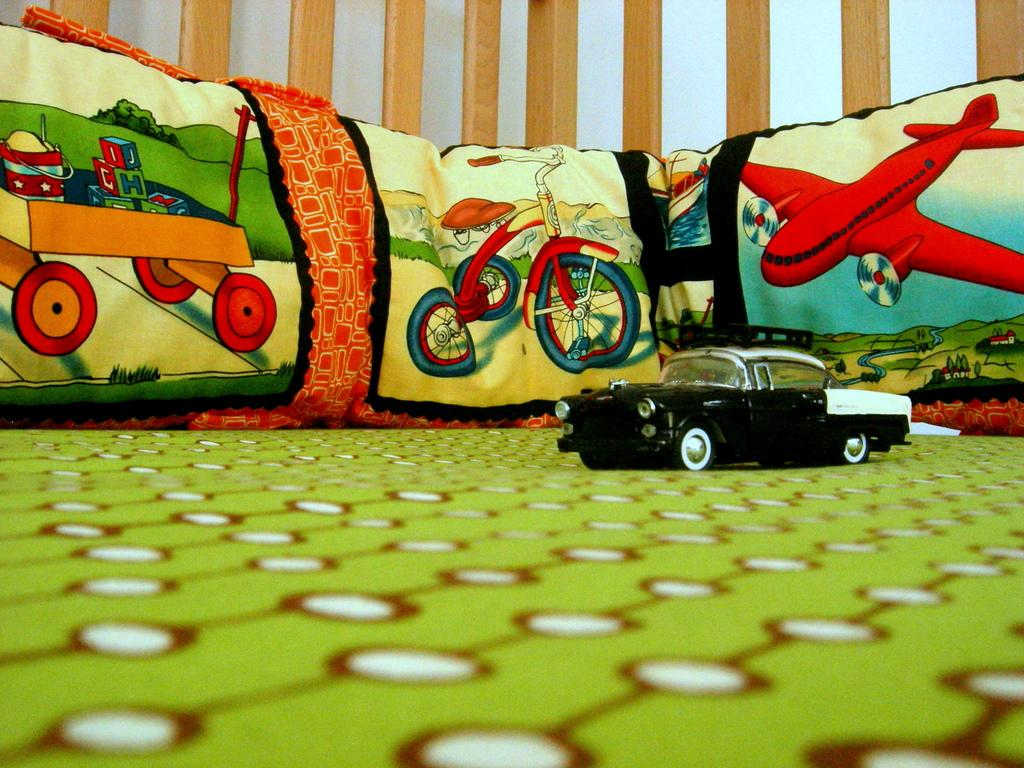What type of furniture is present in the image? There is a bed in the image. What is placed on the bed? There are pillows placed on the bed. What toy can be seen in the image? There is a toy car in the image. What can be seen in the background of the image? There is a wall in the background of the image. What date is circled on the calendar in the image? There is no calendar present in the image, so it is not possible to answer that question. 